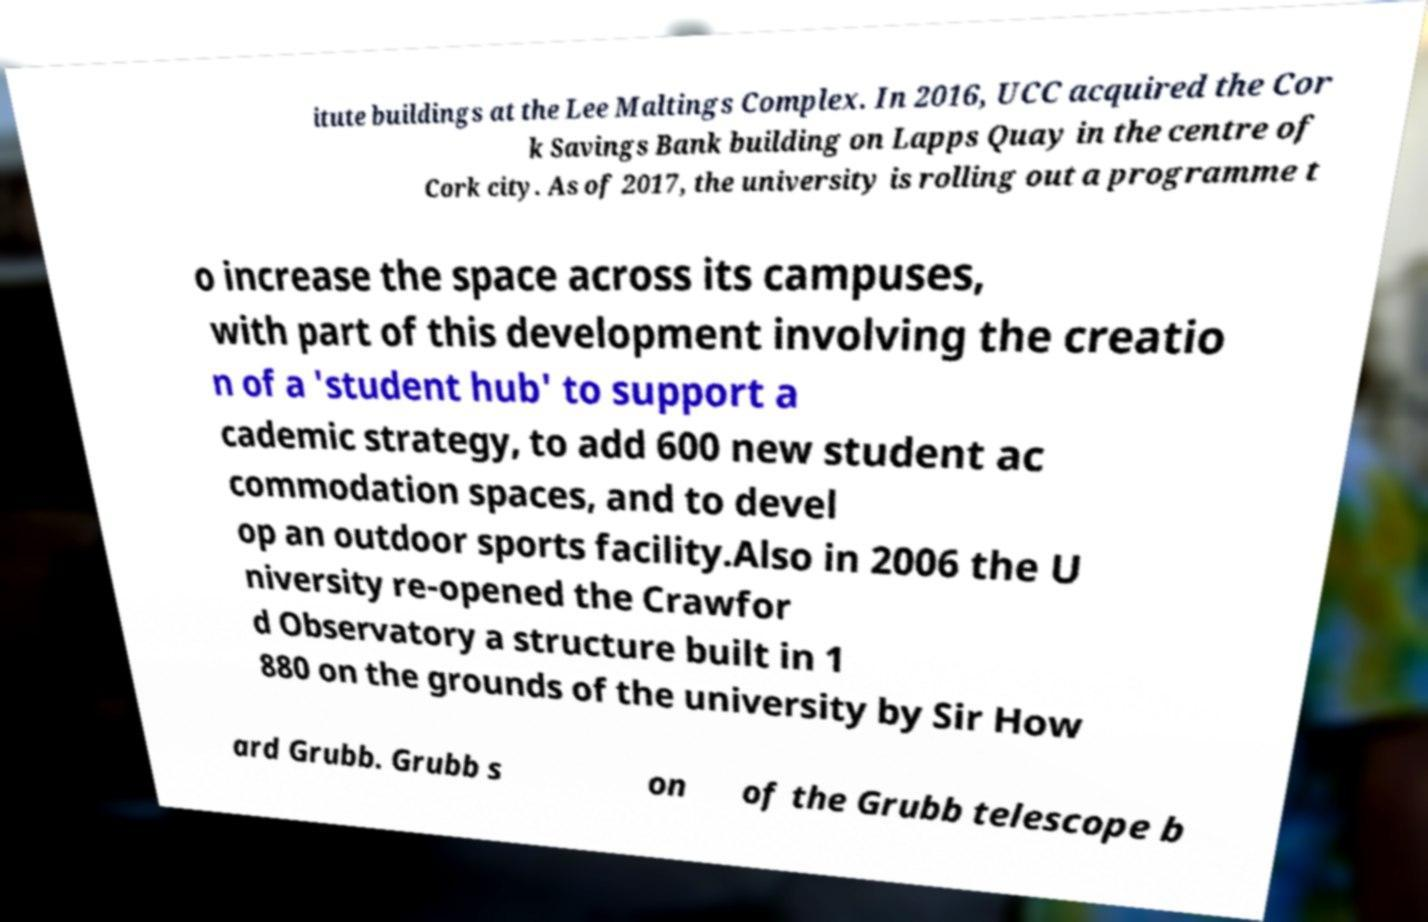Can you read and provide the text displayed in the image?This photo seems to have some interesting text. Can you extract and type it out for me? itute buildings at the Lee Maltings Complex. In 2016, UCC acquired the Cor k Savings Bank building on Lapps Quay in the centre of Cork city. As of 2017, the university is rolling out a programme t o increase the space across its campuses, with part of this development involving the creatio n of a 'student hub' to support a cademic strategy, to add 600 new student ac commodation spaces, and to devel op an outdoor sports facility.Also in 2006 the U niversity re-opened the Crawfor d Observatory a structure built in 1 880 on the grounds of the university by Sir How ard Grubb. Grubb s on of the Grubb telescope b 